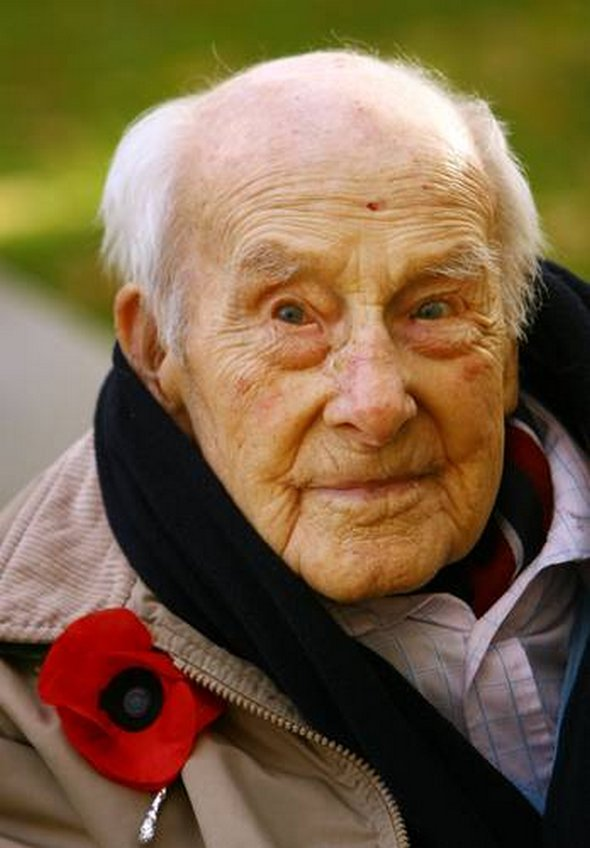What emotions or memories might the man be experiencing during this time? Given the context of Remembrance Day and the visible poppy flower, the man might be reflecting on past experiences, perhaps remembering comrades and loved ones who served in the military. His solemn expression suggests a contemplative state, possibly filled with both pride and sorrow as he honors those who have sacrificed their lives. This moment could be a poignant blend of personal memories and collective commemoration. Can you elaborate on the significance of his attire in this setting? The man's attire, consisting of a warm jacket, scarf, and neatly buttoned shirt, indicates preparation for cooler weather, typical of autumn or early winter. This aligns with the timing of Remembrance Day in November. Moreover, his careful dressing suggests a sense of respect and honor towards the occasion. The red poppy on his lapel reinforces this, symbolizing remembrance and respect for fallen soldiers. This thoughtful attire contributes to the overall solemn and respectful atmosphere of the occasion. What do you think he might be thinking about, specifically? He might be thinking about specific memories from his own experiences, perhaps recalling friends and fellow soldiers who served together. His thoughts could also be encompassing the broader significance of Remembrance Day, reflecting on the historic events of World War I and other conflicts. It's possible that he is lost in memories of camaraderie, bravery, and the profound sense of loss that accompanies war. His thoughts might also be on the resilience and sacrifices made by many, including his own contributions if he has a personal history in the military. 